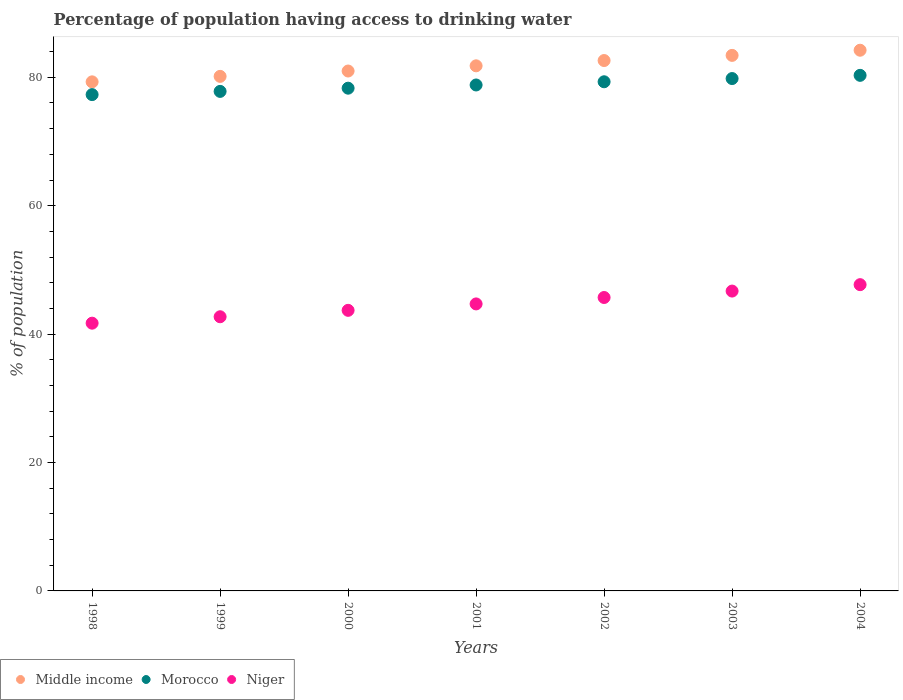What is the percentage of population having access to drinking water in Morocco in 2000?
Offer a terse response. 78.3. Across all years, what is the maximum percentage of population having access to drinking water in Niger?
Your answer should be compact. 47.7. Across all years, what is the minimum percentage of population having access to drinking water in Middle income?
Keep it short and to the point. 79.29. In which year was the percentage of population having access to drinking water in Niger maximum?
Your response must be concise. 2004. What is the total percentage of population having access to drinking water in Niger in the graph?
Ensure brevity in your answer.  312.9. What is the difference between the percentage of population having access to drinking water in Niger in 1999 and that in 2004?
Offer a very short reply. -5. What is the difference between the percentage of population having access to drinking water in Morocco in 2004 and the percentage of population having access to drinking water in Niger in 2002?
Offer a very short reply. 34.6. What is the average percentage of population having access to drinking water in Niger per year?
Offer a very short reply. 44.7. In the year 1998, what is the difference between the percentage of population having access to drinking water in Niger and percentage of population having access to drinking water in Middle income?
Give a very brief answer. -37.59. What is the ratio of the percentage of population having access to drinking water in Morocco in 2001 to that in 2004?
Keep it short and to the point. 0.98. Is the percentage of population having access to drinking water in Niger in 2000 less than that in 2004?
Keep it short and to the point. Yes. What is the difference between the highest and the second highest percentage of population having access to drinking water in Niger?
Your answer should be compact. 1. What is the difference between the highest and the lowest percentage of population having access to drinking water in Middle income?
Make the answer very short. 4.93. Does the percentage of population having access to drinking water in Morocco monotonically increase over the years?
Your response must be concise. Yes. Is the percentage of population having access to drinking water in Niger strictly greater than the percentage of population having access to drinking water in Morocco over the years?
Offer a very short reply. No. Is the percentage of population having access to drinking water in Morocco strictly less than the percentage of population having access to drinking water in Middle income over the years?
Make the answer very short. Yes. How many dotlines are there?
Provide a short and direct response. 3. How many years are there in the graph?
Make the answer very short. 7. Are the values on the major ticks of Y-axis written in scientific E-notation?
Make the answer very short. No. How are the legend labels stacked?
Your response must be concise. Horizontal. What is the title of the graph?
Give a very brief answer. Percentage of population having access to drinking water. What is the label or title of the X-axis?
Ensure brevity in your answer.  Years. What is the label or title of the Y-axis?
Offer a terse response. % of population. What is the % of population of Middle income in 1998?
Make the answer very short. 79.29. What is the % of population in Morocco in 1998?
Offer a very short reply. 77.3. What is the % of population in Niger in 1998?
Your answer should be compact. 41.7. What is the % of population in Middle income in 1999?
Offer a terse response. 80.14. What is the % of population of Morocco in 1999?
Give a very brief answer. 77.8. What is the % of population in Niger in 1999?
Your answer should be compact. 42.7. What is the % of population in Middle income in 2000?
Make the answer very short. 80.97. What is the % of population of Morocco in 2000?
Offer a very short reply. 78.3. What is the % of population of Niger in 2000?
Your answer should be very brief. 43.7. What is the % of population of Middle income in 2001?
Keep it short and to the point. 81.78. What is the % of population of Morocco in 2001?
Ensure brevity in your answer.  78.8. What is the % of population in Niger in 2001?
Give a very brief answer. 44.7. What is the % of population of Middle income in 2002?
Provide a succinct answer. 82.61. What is the % of population of Morocco in 2002?
Your response must be concise. 79.3. What is the % of population in Niger in 2002?
Ensure brevity in your answer.  45.7. What is the % of population of Middle income in 2003?
Offer a very short reply. 83.41. What is the % of population in Morocco in 2003?
Your response must be concise. 79.8. What is the % of population of Niger in 2003?
Keep it short and to the point. 46.7. What is the % of population in Middle income in 2004?
Offer a very short reply. 84.21. What is the % of population in Morocco in 2004?
Offer a very short reply. 80.3. What is the % of population in Niger in 2004?
Give a very brief answer. 47.7. Across all years, what is the maximum % of population of Middle income?
Your response must be concise. 84.21. Across all years, what is the maximum % of population of Morocco?
Offer a very short reply. 80.3. Across all years, what is the maximum % of population in Niger?
Offer a very short reply. 47.7. Across all years, what is the minimum % of population of Middle income?
Your answer should be very brief. 79.29. Across all years, what is the minimum % of population of Morocco?
Your response must be concise. 77.3. Across all years, what is the minimum % of population in Niger?
Your answer should be compact. 41.7. What is the total % of population in Middle income in the graph?
Provide a succinct answer. 572.41. What is the total % of population of Morocco in the graph?
Make the answer very short. 551.6. What is the total % of population of Niger in the graph?
Ensure brevity in your answer.  312.9. What is the difference between the % of population in Middle income in 1998 and that in 1999?
Provide a short and direct response. -0.85. What is the difference between the % of population of Morocco in 1998 and that in 1999?
Your answer should be compact. -0.5. What is the difference between the % of population in Middle income in 1998 and that in 2000?
Your answer should be compact. -1.69. What is the difference between the % of population of Morocco in 1998 and that in 2000?
Your answer should be very brief. -1. What is the difference between the % of population of Niger in 1998 and that in 2000?
Give a very brief answer. -2. What is the difference between the % of population of Middle income in 1998 and that in 2001?
Provide a short and direct response. -2.5. What is the difference between the % of population of Morocco in 1998 and that in 2001?
Give a very brief answer. -1.5. What is the difference between the % of population in Middle income in 1998 and that in 2002?
Make the answer very short. -3.32. What is the difference between the % of population of Niger in 1998 and that in 2002?
Ensure brevity in your answer.  -4. What is the difference between the % of population of Middle income in 1998 and that in 2003?
Provide a short and direct response. -4.12. What is the difference between the % of population in Morocco in 1998 and that in 2003?
Provide a succinct answer. -2.5. What is the difference between the % of population of Niger in 1998 and that in 2003?
Ensure brevity in your answer.  -5. What is the difference between the % of population of Middle income in 1998 and that in 2004?
Make the answer very short. -4.93. What is the difference between the % of population of Morocco in 1998 and that in 2004?
Ensure brevity in your answer.  -3. What is the difference between the % of population in Niger in 1998 and that in 2004?
Keep it short and to the point. -6. What is the difference between the % of population in Middle income in 1999 and that in 2000?
Provide a short and direct response. -0.83. What is the difference between the % of population in Morocco in 1999 and that in 2000?
Offer a terse response. -0.5. What is the difference between the % of population of Middle income in 1999 and that in 2001?
Your answer should be very brief. -1.64. What is the difference between the % of population in Niger in 1999 and that in 2001?
Give a very brief answer. -2. What is the difference between the % of population in Middle income in 1999 and that in 2002?
Offer a terse response. -2.46. What is the difference between the % of population of Morocco in 1999 and that in 2002?
Offer a terse response. -1.5. What is the difference between the % of population of Niger in 1999 and that in 2002?
Your response must be concise. -3. What is the difference between the % of population of Middle income in 1999 and that in 2003?
Offer a very short reply. -3.27. What is the difference between the % of population in Morocco in 1999 and that in 2003?
Your answer should be compact. -2. What is the difference between the % of population in Niger in 1999 and that in 2003?
Make the answer very short. -4. What is the difference between the % of population in Middle income in 1999 and that in 2004?
Offer a terse response. -4.07. What is the difference between the % of population in Niger in 1999 and that in 2004?
Provide a short and direct response. -5. What is the difference between the % of population of Middle income in 2000 and that in 2001?
Your answer should be compact. -0.81. What is the difference between the % of population of Morocco in 2000 and that in 2001?
Keep it short and to the point. -0.5. What is the difference between the % of population of Middle income in 2000 and that in 2002?
Provide a short and direct response. -1.63. What is the difference between the % of population in Morocco in 2000 and that in 2002?
Provide a short and direct response. -1. What is the difference between the % of population in Middle income in 2000 and that in 2003?
Provide a succinct answer. -2.44. What is the difference between the % of population of Niger in 2000 and that in 2003?
Your answer should be compact. -3. What is the difference between the % of population in Middle income in 2000 and that in 2004?
Provide a short and direct response. -3.24. What is the difference between the % of population of Middle income in 2001 and that in 2002?
Make the answer very short. -0.82. What is the difference between the % of population in Morocco in 2001 and that in 2002?
Offer a terse response. -0.5. What is the difference between the % of population of Niger in 2001 and that in 2002?
Offer a terse response. -1. What is the difference between the % of population of Middle income in 2001 and that in 2003?
Offer a very short reply. -1.63. What is the difference between the % of population of Morocco in 2001 and that in 2003?
Ensure brevity in your answer.  -1. What is the difference between the % of population of Niger in 2001 and that in 2003?
Your answer should be compact. -2. What is the difference between the % of population of Middle income in 2001 and that in 2004?
Offer a very short reply. -2.43. What is the difference between the % of population of Morocco in 2001 and that in 2004?
Provide a succinct answer. -1.5. What is the difference between the % of population of Middle income in 2002 and that in 2003?
Make the answer very short. -0.8. What is the difference between the % of population in Morocco in 2002 and that in 2003?
Ensure brevity in your answer.  -0.5. What is the difference between the % of population of Middle income in 2002 and that in 2004?
Your response must be concise. -1.61. What is the difference between the % of population of Morocco in 2002 and that in 2004?
Keep it short and to the point. -1. What is the difference between the % of population in Middle income in 2003 and that in 2004?
Keep it short and to the point. -0.8. What is the difference between the % of population in Niger in 2003 and that in 2004?
Your response must be concise. -1. What is the difference between the % of population in Middle income in 1998 and the % of population in Morocco in 1999?
Your answer should be very brief. 1.49. What is the difference between the % of population of Middle income in 1998 and the % of population of Niger in 1999?
Your answer should be compact. 36.59. What is the difference between the % of population in Morocco in 1998 and the % of population in Niger in 1999?
Offer a terse response. 34.6. What is the difference between the % of population in Middle income in 1998 and the % of population in Niger in 2000?
Offer a very short reply. 35.59. What is the difference between the % of population of Morocco in 1998 and the % of population of Niger in 2000?
Give a very brief answer. 33.6. What is the difference between the % of population in Middle income in 1998 and the % of population in Morocco in 2001?
Your answer should be compact. 0.49. What is the difference between the % of population of Middle income in 1998 and the % of population of Niger in 2001?
Provide a short and direct response. 34.59. What is the difference between the % of population in Morocco in 1998 and the % of population in Niger in 2001?
Ensure brevity in your answer.  32.6. What is the difference between the % of population in Middle income in 1998 and the % of population in Morocco in 2002?
Provide a succinct answer. -0.01. What is the difference between the % of population in Middle income in 1998 and the % of population in Niger in 2002?
Provide a short and direct response. 33.59. What is the difference between the % of population of Morocco in 1998 and the % of population of Niger in 2002?
Your answer should be very brief. 31.6. What is the difference between the % of population in Middle income in 1998 and the % of population in Morocco in 2003?
Your answer should be very brief. -0.51. What is the difference between the % of population in Middle income in 1998 and the % of population in Niger in 2003?
Ensure brevity in your answer.  32.59. What is the difference between the % of population of Morocco in 1998 and the % of population of Niger in 2003?
Offer a very short reply. 30.6. What is the difference between the % of population of Middle income in 1998 and the % of population of Morocco in 2004?
Provide a short and direct response. -1.01. What is the difference between the % of population in Middle income in 1998 and the % of population in Niger in 2004?
Provide a succinct answer. 31.59. What is the difference between the % of population in Morocco in 1998 and the % of population in Niger in 2004?
Offer a very short reply. 29.6. What is the difference between the % of population of Middle income in 1999 and the % of population of Morocco in 2000?
Ensure brevity in your answer.  1.84. What is the difference between the % of population of Middle income in 1999 and the % of population of Niger in 2000?
Provide a succinct answer. 36.44. What is the difference between the % of population in Morocco in 1999 and the % of population in Niger in 2000?
Your answer should be compact. 34.1. What is the difference between the % of population of Middle income in 1999 and the % of population of Morocco in 2001?
Provide a short and direct response. 1.34. What is the difference between the % of population of Middle income in 1999 and the % of population of Niger in 2001?
Provide a succinct answer. 35.44. What is the difference between the % of population of Morocco in 1999 and the % of population of Niger in 2001?
Provide a short and direct response. 33.1. What is the difference between the % of population of Middle income in 1999 and the % of population of Morocco in 2002?
Provide a succinct answer. 0.84. What is the difference between the % of population in Middle income in 1999 and the % of population in Niger in 2002?
Make the answer very short. 34.44. What is the difference between the % of population of Morocco in 1999 and the % of population of Niger in 2002?
Your answer should be compact. 32.1. What is the difference between the % of population of Middle income in 1999 and the % of population of Morocco in 2003?
Give a very brief answer. 0.34. What is the difference between the % of population of Middle income in 1999 and the % of population of Niger in 2003?
Offer a very short reply. 33.44. What is the difference between the % of population in Morocco in 1999 and the % of population in Niger in 2003?
Your answer should be compact. 31.1. What is the difference between the % of population of Middle income in 1999 and the % of population of Morocco in 2004?
Give a very brief answer. -0.16. What is the difference between the % of population in Middle income in 1999 and the % of population in Niger in 2004?
Provide a short and direct response. 32.44. What is the difference between the % of population of Morocco in 1999 and the % of population of Niger in 2004?
Ensure brevity in your answer.  30.1. What is the difference between the % of population of Middle income in 2000 and the % of population of Morocco in 2001?
Provide a succinct answer. 2.17. What is the difference between the % of population in Middle income in 2000 and the % of population in Niger in 2001?
Provide a succinct answer. 36.27. What is the difference between the % of population in Morocco in 2000 and the % of population in Niger in 2001?
Make the answer very short. 33.6. What is the difference between the % of population in Middle income in 2000 and the % of population in Morocco in 2002?
Provide a succinct answer. 1.67. What is the difference between the % of population in Middle income in 2000 and the % of population in Niger in 2002?
Your answer should be compact. 35.27. What is the difference between the % of population in Morocco in 2000 and the % of population in Niger in 2002?
Provide a short and direct response. 32.6. What is the difference between the % of population in Middle income in 2000 and the % of population in Morocco in 2003?
Keep it short and to the point. 1.17. What is the difference between the % of population of Middle income in 2000 and the % of population of Niger in 2003?
Give a very brief answer. 34.27. What is the difference between the % of population in Morocco in 2000 and the % of population in Niger in 2003?
Keep it short and to the point. 31.6. What is the difference between the % of population in Middle income in 2000 and the % of population in Morocco in 2004?
Offer a terse response. 0.67. What is the difference between the % of population of Middle income in 2000 and the % of population of Niger in 2004?
Keep it short and to the point. 33.27. What is the difference between the % of population in Morocco in 2000 and the % of population in Niger in 2004?
Offer a terse response. 30.6. What is the difference between the % of population in Middle income in 2001 and the % of population in Morocco in 2002?
Offer a terse response. 2.48. What is the difference between the % of population of Middle income in 2001 and the % of population of Niger in 2002?
Offer a very short reply. 36.08. What is the difference between the % of population in Morocco in 2001 and the % of population in Niger in 2002?
Offer a terse response. 33.1. What is the difference between the % of population in Middle income in 2001 and the % of population in Morocco in 2003?
Provide a short and direct response. 1.98. What is the difference between the % of population in Middle income in 2001 and the % of population in Niger in 2003?
Your answer should be compact. 35.08. What is the difference between the % of population of Morocco in 2001 and the % of population of Niger in 2003?
Provide a succinct answer. 32.1. What is the difference between the % of population of Middle income in 2001 and the % of population of Morocco in 2004?
Offer a very short reply. 1.48. What is the difference between the % of population of Middle income in 2001 and the % of population of Niger in 2004?
Make the answer very short. 34.08. What is the difference between the % of population in Morocco in 2001 and the % of population in Niger in 2004?
Provide a short and direct response. 31.1. What is the difference between the % of population in Middle income in 2002 and the % of population in Morocco in 2003?
Your answer should be very brief. 2.81. What is the difference between the % of population of Middle income in 2002 and the % of population of Niger in 2003?
Your answer should be very brief. 35.91. What is the difference between the % of population in Morocco in 2002 and the % of population in Niger in 2003?
Provide a short and direct response. 32.6. What is the difference between the % of population in Middle income in 2002 and the % of population in Morocco in 2004?
Ensure brevity in your answer.  2.31. What is the difference between the % of population in Middle income in 2002 and the % of population in Niger in 2004?
Provide a short and direct response. 34.91. What is the difference between the % of population of Morocco in 2002 and the % of population of Niger in 2004?
Your answer should be very brief. 31.6. What is the difference between the % of population of Middle income in 2003 and the % of population of Morocco in 2004?
Provide a succinct answer. 3.11. What is the difference between the % of population in Middle income in 2003 and the % of population in Niger in 2004?
Make the answer very short. 35.71. What is the difference between the % of population in Morocco in 2003 and the % of population in Niger in 2004?
Provide a short and direct response. 32.1. What is the average % of population of Middle income per year?
Your answer should be very brief. 81.77. What is the average % of population of Morocco per year?
Ensure brevity in your answer.  78.8. What is the average % of population in Niger per year?
Offer a terse response. 44.7. In the year 1998, what is the difference between the % of population of Middle income and % of population of Morocco?
Your answer should be compact. 1.99. In the year 1998, what is the difference between the % of population of Middle income and % of population of Niger?
Ensure brevity in your answer.  37.59. In the year 1998, what is the difference between the % of population in Morocco and % of population in Niger?
Your response must be concise. 35.6. In the year 1999, what is the difference between the % of population in Middle income and % of population in Morocco?
Make the answer very short. 2.34. In the year 1999, what is the difference between the % of population of Middle income and % of population of Niger?
Ensure brevity in your answer.  37.44. In the year 1999, what is the difference between the % of population in Morocco and % of population in Niger?
Your answer should be very brief. 35.1. In the year 2000, what is the difference between the % of population of Middle income and % of population of Morocco?
Keep it short and to the point. 2.67. In the year 2000, what is the difference between the % of population in Middle income and % of population in Niger?
Your answer should be compact. 37.27. In the year 2000, what is the difference between the % of population in Morocco and % of population in Niger?
Your response must be concise. 34.6. In the year 2001, what is the difference between the % of population of Middle income and % of population of Morocco?
Provide a short and direct response. 2.98. In the year 2001, what is the difference between the % of population in Middle income and % of population in Niger?
Make the answer very short. 37.08. In the year 2001, what is the difference between the % of population of Morocco and % of population of Niger?
Keep it short and to the point. 34.1. In the year 2002, what is the difference between the % of population in Middle income and % of population in Morocco?
Offer a very short reply. 3.31. In the year 2002, what is the difference between the % of population of Middle income and % of population of Niger?
Keep it short and to the point. 36.91. In the year 2002, what is the difference between the % of population in Morocco and % of population in Niger?
Offer a very short reply. 33.6. In the year 2003, what is the difference between the % of population of Middle income and % of population of Morocco?
Ensure brevity in your answer.  3.61. In the year 2003, what is the difference between the % of population of Middle income and % of population of Niger?
Your response must be concise. 36.71. In the year 2003, what is the difference between the % of population in Morocco and % of population in Niger?
Your answer should be compact. 33.1. In the year 2004, what is the difference between the % of population in Middle income and % of population in Morocco?
Offer a terse response. 3.91. In the year 2004, what is the difference between the % of population of Middle income and % of population of Niger?
Your answer should be very brief. 36.51. In the year 2004, what is the difference between the % of population of Morocco and % of population of Niger?
Ensure brevity in your answer.  32.6. What is the ratio of the % of population of Middle income in 1998 to that in 1999?
Offer a terse response. 0.99. What is the ratio of the % of population in Morocco in 1998 to that in 1999?
Make the answer very short. 0.99. What is the ratio of the % of population of Niger in 1998 to that in 1999?
Offer a very short reply. 0.98. What is the ratio of the % of population of Middle income in 1998 to that in 2000?
Make the answer very short. 0.98. What is the ratio of the % of population in Morocco in 1998 to that in 2000?
Make the answer very short. 0.99. What is the ratio of the % of population of Niger in 1998 to that in 2000?
Your answer should be compact. 0.95. What is the ratio of the % of population in Middle income in 1998 to that in 2001?
Make the answer very short. 0.97. What is the ratio of the % of population of Niger in 1998 to that in 2001?
Your answer should be very brief. 0.93. What is the ratio of the % of population of Middle income in 1998 to that in 2002?
Make the answer very short. 0.96. What is the ratio of the % of population of Morocco in 1998 to that in 2002?
Offer a very short reply. 0.97. What is the ratio of the % of population of Niger in 1998 to that in 2002?
Your answer should be compact. 0.91. What is the ratio of the % of population of Middle income in 1998 to that in 2003?
Provide a succinct answer. 0.95. What is the ratio of the % of population of Morocco in 1998 to that in 2003?
Give a very brief answer. 0.97. What is the ratio of the % of population of Niger in 1998 to that in 2003?
Offer a terse response. 0.89. What is the ratio of the % of population in Middle income in 1998 to that in 2004?
Your response must be concise. 0.94. What is the ratio of the % of population of Morocco in 1998 to that in 2004?
Your answer should be compact. 0.96. What is the ratio of the % of population in Niger in 1998 to that in 2004?
Ensure brevity in your answer.  0.87. What is the ratio of the % of population of Middle income in 1999 to that in 2000?
Offer a very short reply. 0.99. What is the ratio of the % of population of Morocco in 1999 to that in 2000?
Keep it short and to the point. 0.99. What is the ratio of the % of population in Niger in 1999 to that in 2000?
Your response must be concise. 0.98. What is the ratio of the % of population in Middle income in 1999 to that in 2001?
Give a very brief answer. 0.98. What is the ratio of the % of population of Morocco in 1999 to that in 2001?
Offer a very short reply. 0.99. What is the ratio of the % of population of Niger in 1999 to that in 2001?
Offer a very short reply. 0.96. What is the ratio of the % of population of Middle income in 1999 to that in 2002?
Your answer should be compact. 0.97. What is the ratio of the % of population in Morocco in 1999 to that in 2002?
Offer a very short reply. 0.98. What is the ratio of the % of population of Niger in 1999 to that in 2002?
Your response must be concise. 0.93. What is the ratio of the % of population of Middle income in 1999 to that in 2003?
Your response must be concise. 0.96. What is the ratio of the % of population in Morocco in 1999 to that in 2003?
Keep it short and to the point. 0.97. What is the ratio of the % of population in Niger in 1999 to that in 2003?
Your answer should be compact. 0.91. What is the ratio of the % of population in Middle income in 1999 to that in 2004?
Offer a very short reply. 0.95. What is the ratio of the % of population in Morocco in 1999 to that in 2004?
Offer a very short reply. 0.97. What is the ratio of the % of population in Niger in 1999 to that in 2004?
Offer a terse response. 0.9. What is the ratio of the % of population of Middle income in 2000 to that in 2001?
Offer a terse response. 0.99. What is the ratio of the % of population of Morocco in 2000 to that in 2001?
Ensure brevity in your answer.  0.99. What is the ratio of the % of population in Niger in 2000 to that in 2001?
Provide a short and direct response. 0.98. What is the ratio of the % of population in Middle income in 2000 to that in 2002?
Your response must be concise. 0.98. What is the ratio of the % of population in Morocco in 2000 to that in 2002?
Your answer should be very brief. 0.99. What is the ratio of the % of population in Niger in 2000 to that in 2002?
Your response must be concise. 0.96. What is the ratio of the % of population in Middle income in 2000 to that in 2003?
Make the answer very short. 0.97. What is the ratio of the % of population of Morocco in 2000 to that in 2003?
Offer a very short reply. 0.98. What is the ratio of the % of population of Niger in 2000 to that in 2003?
Your response must be concise. 0.94. What is the ratio of the % of population of Middle income in 2000 to that in 2004?
Make the answer very short. 0.96. What is the ratio of the % of population in Morocco in 2000 to that in 2004?
Offer a terse response. 0.98. What is the ratio of the % of population in Niger in 2000 to that in 2004?
Make the answer very short. 0.92. What is the ratio of the % of population in Morocco in 2001 to that in 2002?
Ensure brevity in your answer.  0.99. What is the ratio of the % of population of Niger in 2001 to that in 2002?
Your answer should be compact. 0.98. What is the ratio of the % of population in Middle income in 2001 to that in 2003?
Keep it short and to the point. 0.98. What is the ratio of the % of population of Morocco in 2001 to that in 2003?
Provide a short and direct response. 0.99. What is the ratio of the % of population in Niger in 2001 to that in 2003?
Make the answer very short. 0.96. What is the ratio of the % of population in Middle income in 2001 to that in 2004?
Offer a terse response. 0.97. What is the ratio of the % of population in Morocco in 2001 to that in 2004?
Give a very brief answer. 0.98. What is the ratio of the % of population in Niger in 2001 to that in 2004?
Provide a short and direct response. 0.94. What is the ratio of the % of population in Niger in 2002 to that in 2003?
Provide a succinct answer. 0.98. What is the ratio of the % of population in Middle income in 2002 to that in 2004?
Your answer should be compact. 0.98. What is the ratio of the % of population in Morocco in 2002 to that in 2004?
Your answer should be very brief. 0.99. What is the ratio of the % of population in Niger in 2002 to that in 2004?
Offer a terse response. 0.96. What is the ratio of the % of population in Niger in 2003 to that in 2004?
Offer a very short reply. 0.98. What is the difference between the highest and the second highest % of population in Middle income?
Give a very brief answer. 0.8. What is the difference between the highest and the second highest % of population of Morocco?
Keep it short and to the point. 0.5. What is the difference between the highest and the lowest % of population of Middle income?
Provide a succinct answer. 4.93. What is the difference between the highest and the lowest % of population in Morocco?
Provide a succinct answer. 3. 